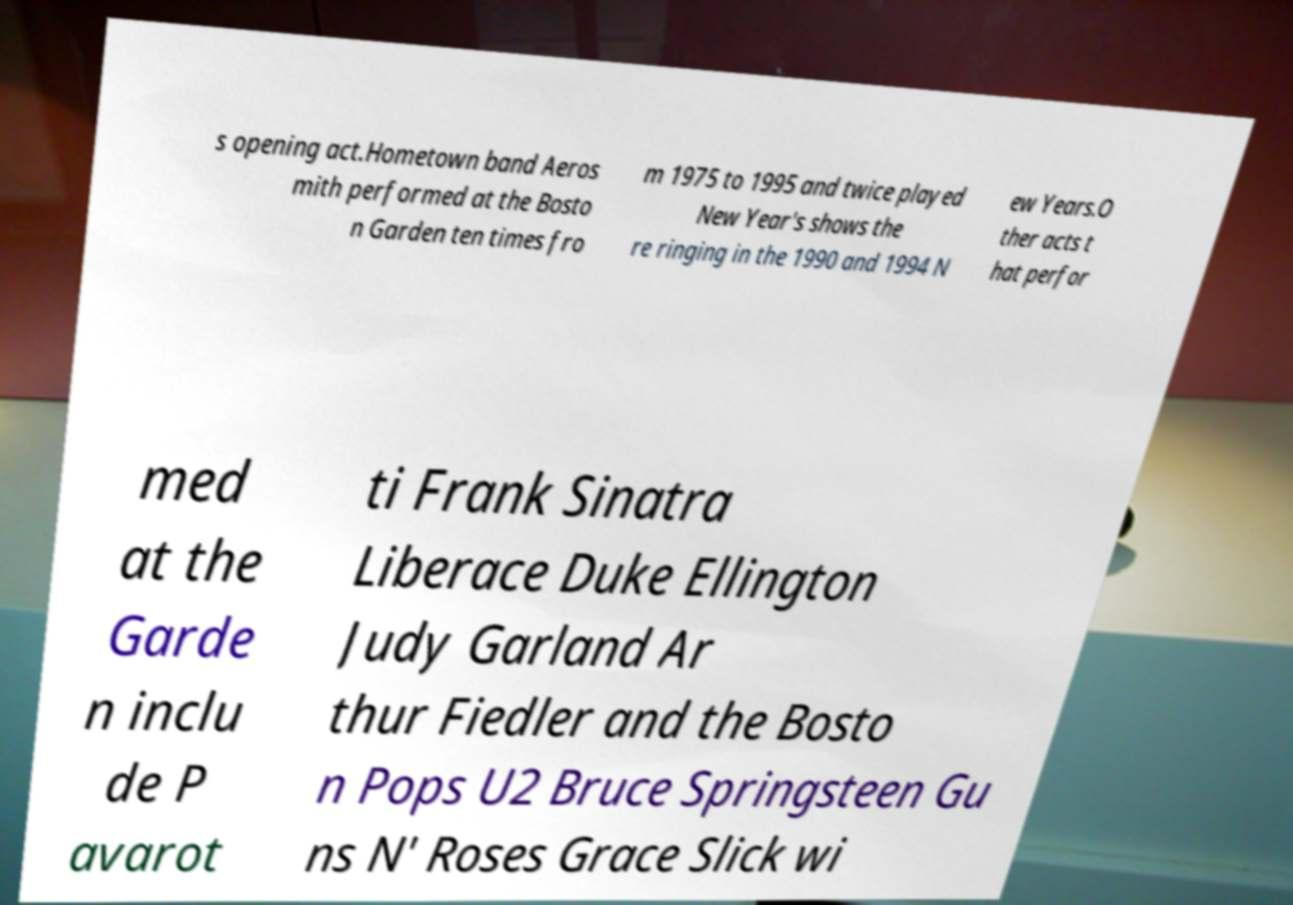Can you read and provide the text displayed in the image?This photo seems to have some interesting text. Can you extract and type it out for me? s opening act.Hometown band Aeros mith performed at the Bosto n Garden ten times fro m 1975 to 1995 and twice played New Year's shows the re ringing in the 1990 and 1994 N ew Years.O ther acts t hat perfor med at the Garde n inclu de P avarot ti Frank Sinatra Liberace Duke Ellington Judy Garland Ar thur Fiedler and the Bosto n Pops U2 Bruce Springsteen Gu ns N' Roses Grace Slick wi 